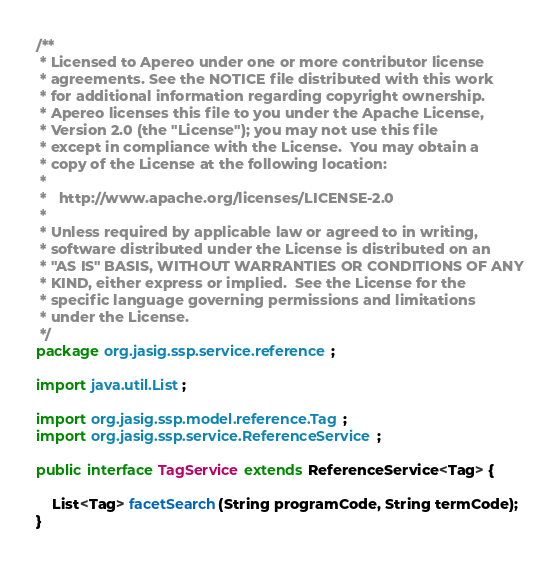Convert code to text. <code><loc_0><loc_0><loc_500><loc_500><_Java_>/**
 * Licensed to Apereo under one or more contributor license
 * agreements. See the NOTICE file distributed with this work
 * for additional information regarding copyright ownership.
 * Apereo licenses this file to you under the Apache License,
 * Version 2.0 (the "License"); you may not use this file
 * except in compliance with the License.  You may obtain a
 * copy of the License at the following location:
 *
 *   http://www.apache.org/licenses/LICENSE-2.0
 *
 * Unless required by applicable law or agreed to in writing,
 * software distributed under the License is distributed on an
 * "AS IS" BASIS, WITHOUT WARRANTIES OR CONDITIONS OF ANY
 * KIND, either express or implied.  See the License for the
 * specific language governing permissions and limitations
 * under the License.
 */
package org.jasig.ssp.service.reference;

import java.util.List;

import org.jasig.ssp.model.reference.Tag;
import org.jasig.ssp.service.ReferenceService;

public interface TagService extends ReferenceService<Tag> {

	List<Tag> facetSearch(String programCode, String termCode);
}
</code> 